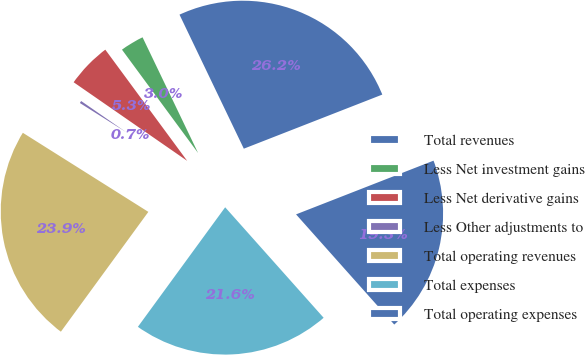Convert chart. <chart><loc_0><loc_0><loc_500><loc_500><pie_chart><fcel>Total revenues<fcel>Less Net investment gains<fcel>Less Net derivative gains<fcel>Less Other adjustments to<fcel>Total operating revenues<fcel>Total expenses<fcel>Total operating expenses<nl><fcel>26.19%<fcel>2.98%<fcel>5.26%<fcel>0.69%<fcel>23.91%<fcel>21.62%<fcel>19.34%<nl></chart> 